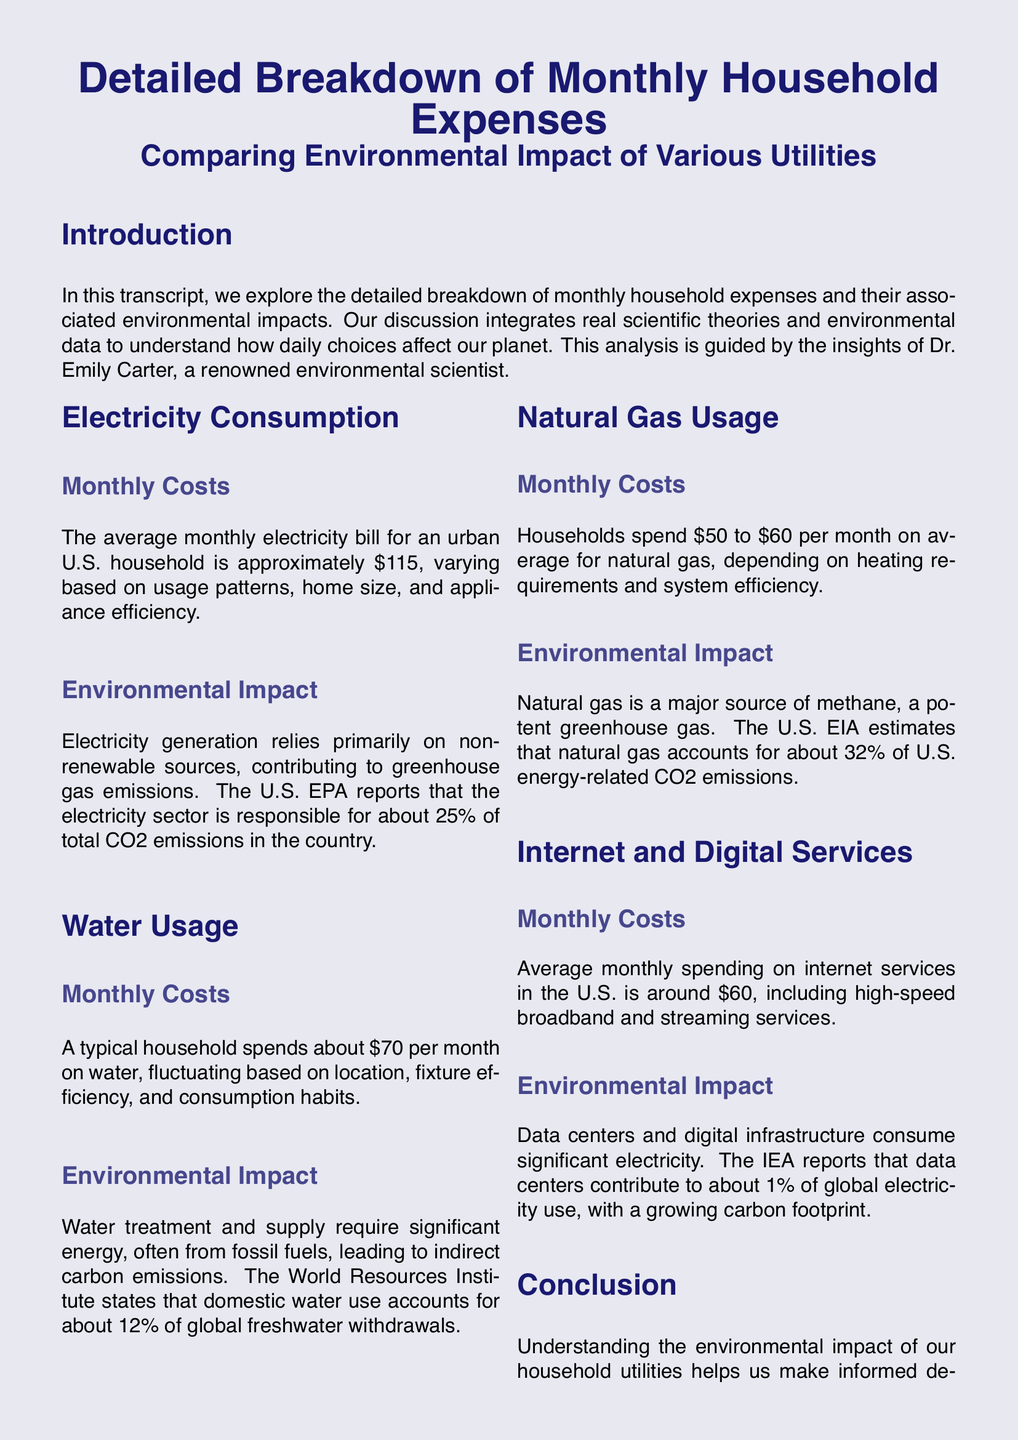What is the average monthly electricity bill? The document states that the average monthly electricity bill for an urban U.S. household is approximately $115.
Answer: $115 What is the average monthly cost of water? The document mentions that a typical household spends about $70 per month on water.
Answer: $70 What percentage of total CO2 emissions is the electricity sector responsible for? According to the document, the electricity sector is responsible for about 25% of total CO2 emissions in the country.
Answer: 25% What is the environmental impact of data centers? The document reports that data centers contribute to about 1% of global electricity use, indicating their growing carbon footprint.
Answer: 1% What is the average monthly spending on internet services? The document indicates that average monthly spending on internet services in the U.S. is around $60.
Answer: $60 What major greenhouse gas is associated with natural gas? The document states that natural gas is a major source of methane, which is a potent greenhouse gas.
Answer: Methane What percentage of global freshwater withdrawals is domestic water use accountable for? The document states that domestic water use accounts for about 12% of global freshwater withdrawals.
Answer: 12% What is suggested to minimize carbon footprint? The document suggests that simple actions such as using energy-efficient appliances and conserving water can help minimize carbon footprint.
Answer: Energy-efficient appliances How many months does the analysis cover? The analysis discusses monthly household expenses, indicating it covers a single month.
Answer: One month Who is the noted environmental scientist in the document? The document mentions Dr. Emily Carter as the renowned environmental scientist guiding the analysis.
Answer: Dr. Emily Carter 